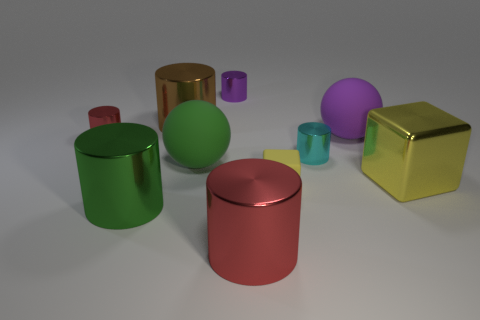What material is the big red thing that is the same shape as the brown shiny thing?
Keep it short and to the point. Metal. Are there more green objects than small metallic things?
Ensure brevity in your answer.  No. What is the material of the big green cylinder?
Give a very brief answer. Metal. There is a matte ball that is on the left side of the cyan object; is its size the same as the big brown thing?
Ensure brevity in your answer.  Yes. There is a yellow block in front of the large yellow metallic block; how big is it?
Keep it short and to the point. Small. How many large brown things are there?
Your response must be concise. 1. Is the metallic cube the same color as the small cube?
Your answer should be compact. Yes. The tiny shiny cylinder that is both in front of the big brown cylinder and on the right side of the large brown cylinder is what color?
Give a very brief answer. Cyan. There is a yellow shiny object; are there any small purple metal cylinders behind it?
Give a very brief answer. Yes. There is a red cylinder that is behind the green cylinder; what number of big green rubber objects are to the right of it?
Make the answer very short. 1. 